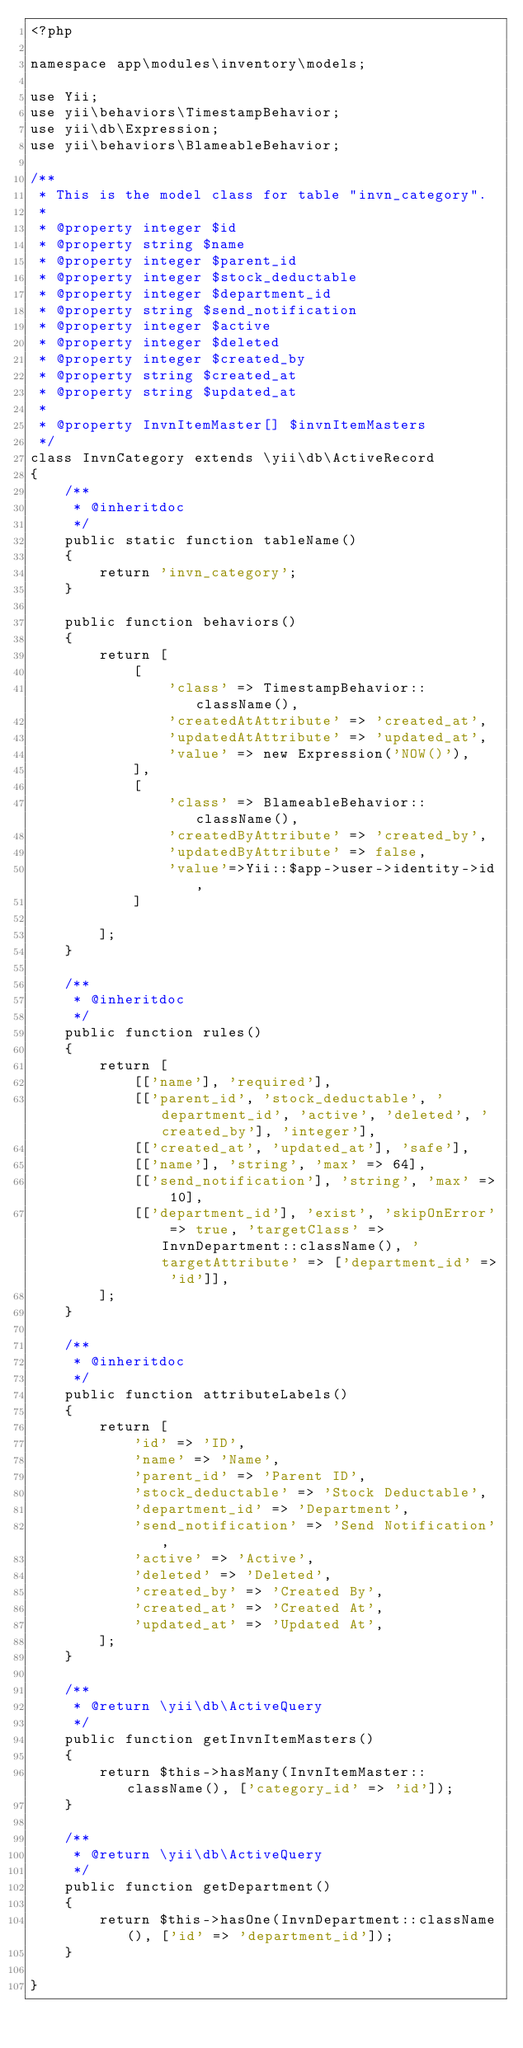<code> <loc_0><loc_0><loc_500><loc_500><_PHP_><?php

namespace app\modules\inventory\models;

use Yii;
use yii\behaviors\TimestampBehavior;
use yii\db\Expression;
use yii\behaviors\BlameableBehavior;

/**
 * This is the model class for table "invn_category".
 *
 * @property integer $id
 * @property string $name
 * @property integer $parent_id
 * @property integer $stock_deductable
 * @property integer $department_id
 * @property string $send_notification
 * @property integer $active
 * @property integer $deleted
 * @property integer $created_by
 * @property string $created_at
 * @property string $updated_at
 *
 * @property InvnItemMaster[] $invnItemMasters
 */
class InvnCategory extends \yii\db\ActiveRecord
{
    /**
     * @inheritdoc
     */
    public static function tableName()
    {
        return 'invn_category';
    }

    public function behaviors()
    {
        return [
            [
                'class' => TimestampBehavior::className(),
                'createdAtAttribute' => 'created_at',
                'updatedAtAttribute' => 'updated_at',
                'value' => new Expression('NOW()'),
            ],
            [
                'class' => BlameableBehavior::className(),
                'createdByAttribute' => 'created_by',
                'updatedByAttribute' => false,
                'value'=>Yii::$app->user->identity->id,
            ]

        ];
    }

    /**
     * @inheritdoc
     */
    public function rules()
    {
        return [
            [['name'], 'required'],
            [['parent_id', 'stock_deductable', 'department_id', 'active', 'deleted', 'created_by'], 'integer'],
            [['created_at', 'updated_at'], 'safe'],
            [['name'], 'string', 'max' => 64],
            [['send_notification'], 'string', 'max' => 10],
            [['department_id'], 'exist', 'skipOnError' => true, 'targetClass' => InvnDepartment::className(), 'targetAttribute' => ['department_id' => 'id']],
        ];
    }

    /**
     * @inheritdoc
     */
    public function attributeLabels()
    {
        return [
            'id' => 'ID',
            'name' => 'Name',
            'parent_id' => 'Parent ID',
            'stock_deductable' => 'Stock Deductable',
            'department_id' => 'Department',
            'send_notification' => 'Send Notification',
            'active' => 'Active',
            'deleted' => 'Deleted',
            'created_by' => 'Created By',
            'created_at' => 'Created At',
            'updated_at' => 'Updated At',
        ];
    }

    /**
     * @return \yii\db\ActiveQuery
     */
    public function getInvnItemMasters()
    {
        return $this->hasMany(InvnItemMaster::className(), ['category_id' => 'id']);
    }
    
    /**
     * @return \yii\db\ActiveQuery
     */
    public function getDepartment()
    {
        return $this->hasOne(InvnDepartment::className(), ['id' => 'department_id']);
    }
    
}
</code> 